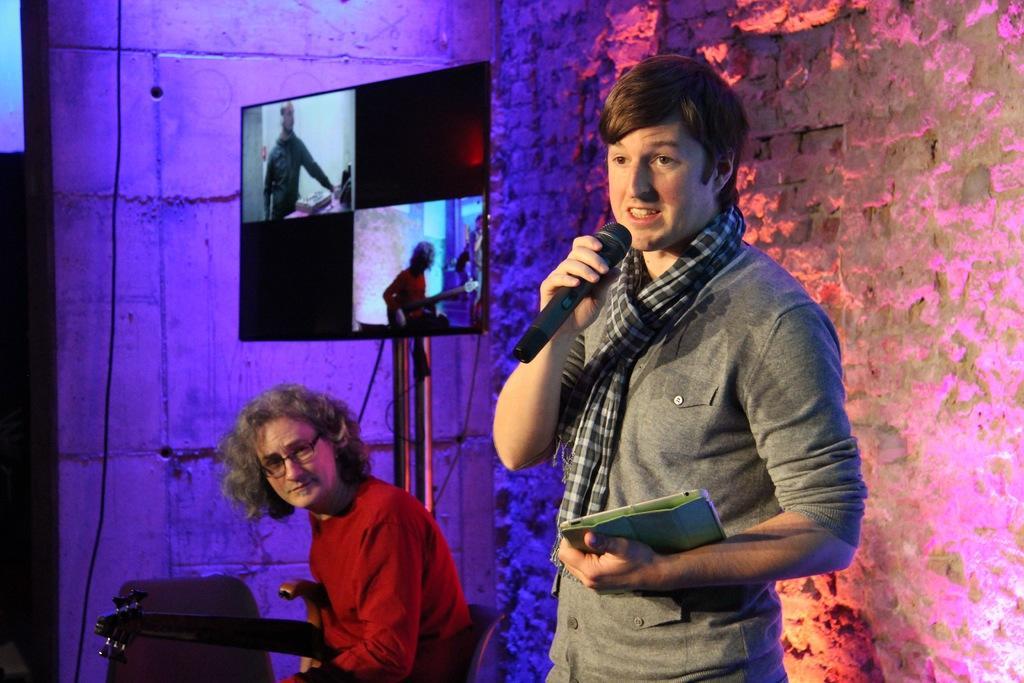Could you give a brief overview of what you see in this image? In this image I can see a man standing, holding a book in his left hand and mike in his right hand and it seems like he's speaking something. In the background I can see a wall. Beside this person there is another person wearing red color t-shirt and sitting on the chair. Behind this person there is a screen. 